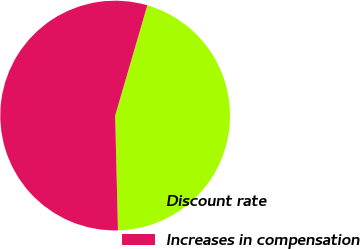<chart> <loc_0><loc_0><loc_500><loc_500><pie_chart><fcel>Discount rate<fcel>Increases in compensation<nl><fcel>45.09%<fcel>54.91%<nl></chart> 